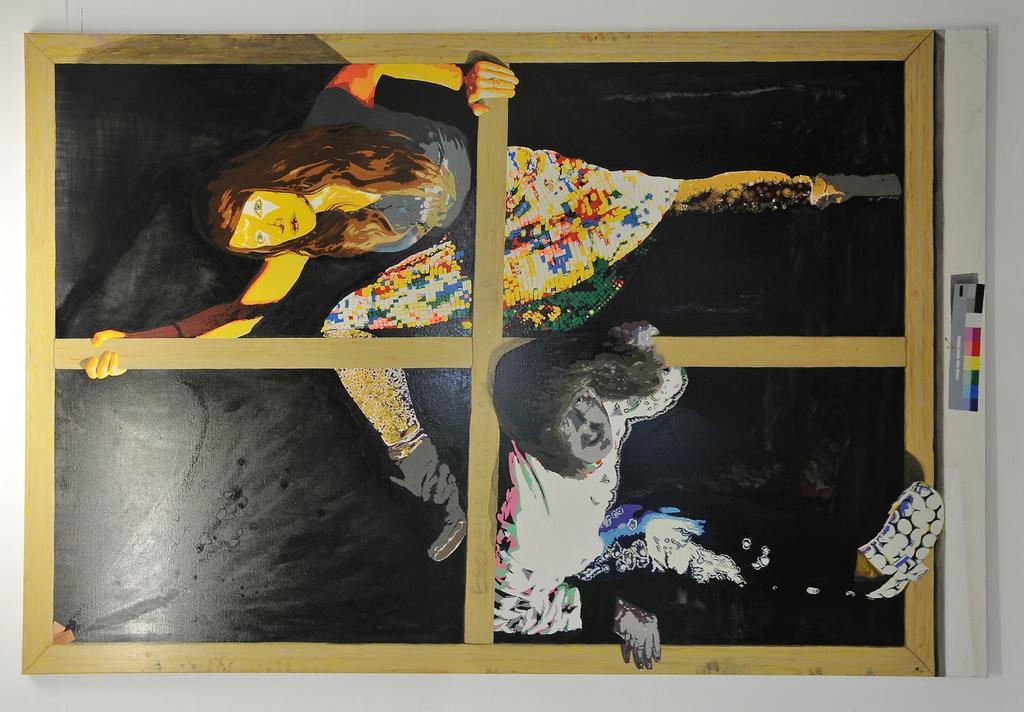Describe this image in one or two sentences. In this image we can see painting of persons on the board. Here we can see wall. 